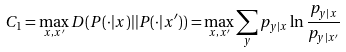<formula> <loc_0><loc_0><loc_500><loc_500>C _ { 1 } = \max _ { x , x ^ { \prime } } D ( P ( \cdot | x ) | | P ( \cdot | x ^ { \prime } ) ) = \max _ { x , x ^ { \prime } } \sum _ { y } p _ { y | x } \ln \frac { p _ { y | x } } { p _ { y | x ^ { \prime } } }</formula> 